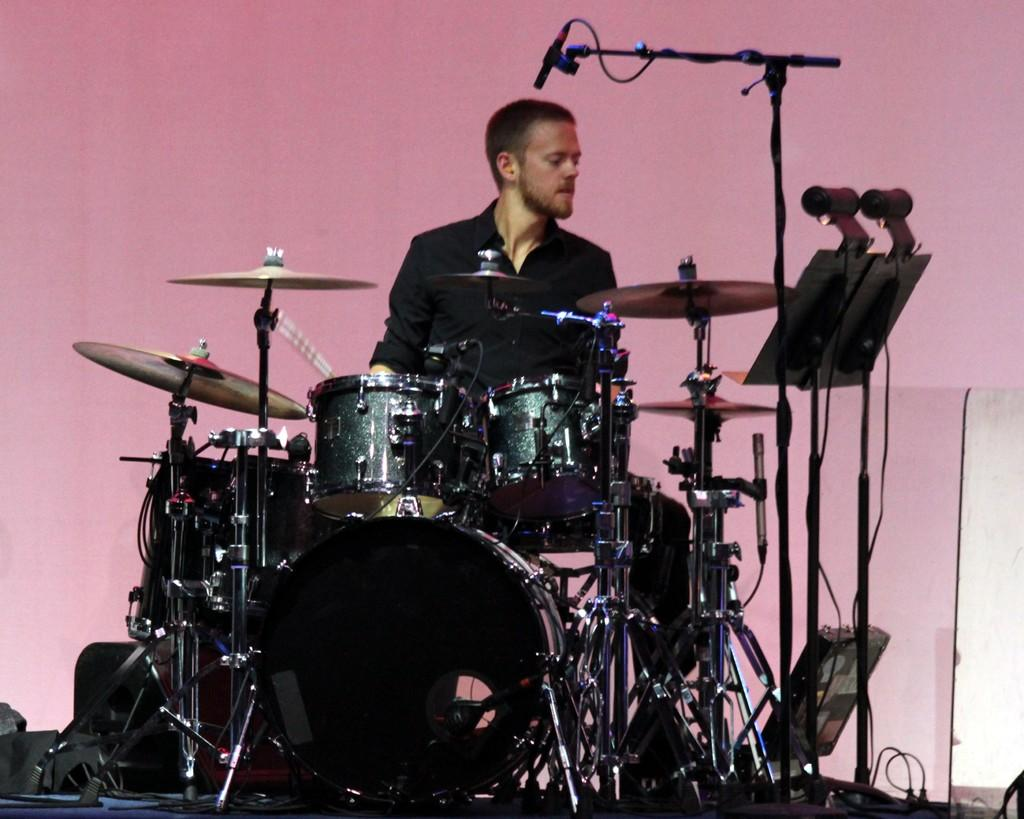What is present in the image? There is a person in the image. Can you describe the person's attire? The person is wearing clothes. What is the person doing in the image? The person is sitting in front of musical instruments. What type of plough is the person using in the image? There is no plough present in the image; the person is sitting in front of musical instruments. 